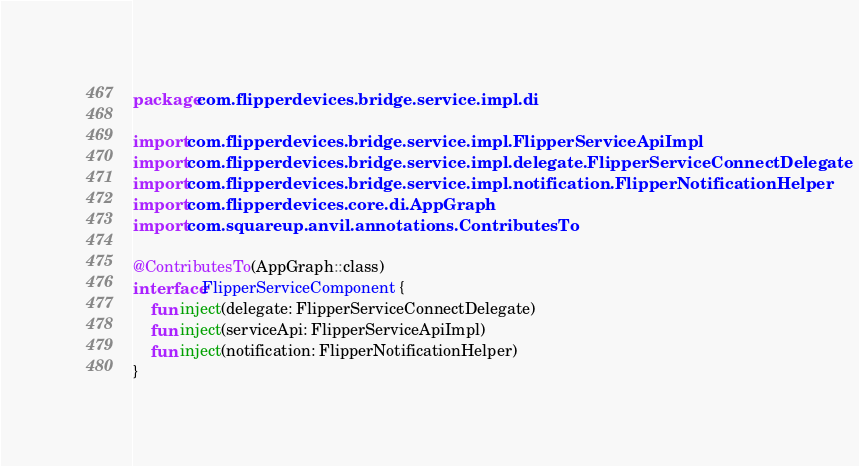Convert code to text. <code><loc_0><loc_0><loc_500><loc_500><_Kotlin_>package com.flipperdevices.bridge.service.impl.di

import com.flipperdevices.bridge.service.impl.FlipperServiceApiImpl
import com.flipperdevices.bridge.service.impl.delegate.FlipperServiceConnectDelegate
import com.flipperdevices.bridge.service.impl.notification.FlipperNotificationHelper
import com.flipperdevices.core.di.AppGraph
import com.squareup.anvil.annotations.ContributesTo

@ContributesTo(AppGraph::class)
interface FlipperServiceComponent {
    fun inject(delegate: FlipperServiceConnectDelegate)
    fun inject(serviceApi: FlipperServiceApiImpl)
    fun inject(notification: FlipperNotificationHelper)
}
</code> 